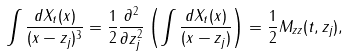<formula> <loc_0><loc_0><loc_500><loc_500>\int \frac { d X _ { t } ( x ) } { ( x - z _ { j } ) ^ { 3 } } = \frac { 1 } { 2 } \frac { \partial ^ { 2 } } { \partial z _ { j } ^ { 2 } } \left ( \int \frac { d X _ { t } ( x ) } { ( x - z _ { j } ) } \right ) = \frac { 1 } { 2 } M _ { z z } ( t , z _ { j } ) ,</formula> 